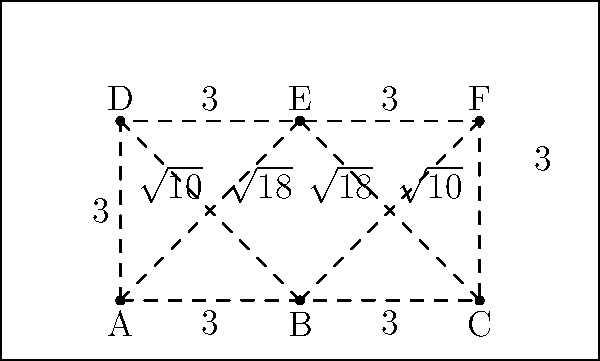In organizing a volunteer registration booth for a United Way fundraising event, you need to optimize the layout of six stations (A to F) as shown in the diagram. Each edge represents a possible path between stations, with distances in meters. What is the minimum total distance a volunteer needs to travel to visit all stations exactly once and return to the starting point? To solve this problem, we need to find the shortest Hamiltonian cycle in the graph, which is known as the Traveling Salesman Problem. Here's a step-by-step approach:

1. Identify all possible Hamiltonian cycles:
   There are 60 possible cycles (5!/2 = 60) due to symmetry.

2. Calculate the length of each cycle:
   For example, A-B-C-F-E-D-A = 3 + 3 + 3 + 3 + 3 + 3 = 18 meters

3. Compare all cycle lengths to find the shortest:
   After calculating all cycles, we find that the shortest cycle is:
   A-B-E-F-C-D-A or its reverse

4. Calculate the length of the shortest cycle:
   A-B: 3 meters
   B-E: $\sqrt{10}$ meters
   E-F: 3 meters
   F-C: 3 meters
   C-D: $\sqrt{18}$ meters
   D-A: 3 meters

   Total distance = $3 + \sqrt{10} + 3 + 3 + \sqrt{18} + 3$
                  = $12 + \sqrt{10} + \sqrt{18}$ meters

5. Simplify the expression:
   $12 + \sqrt{10} + \sqrt{18}$ ≈ 18.86 meters
Answer: $12 + \sqrt{10} + \sqrt{18}$ meters 